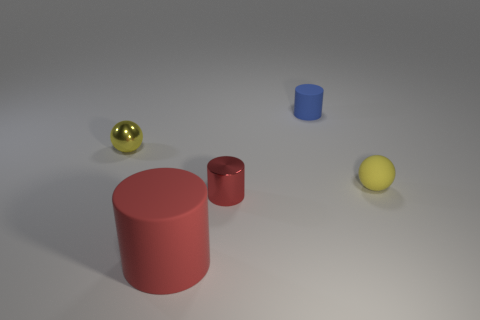Is there any other thing that has the same size as the red matte thing?
Your answer should be compact. No. The big red thing has what shape?
Give a very brief answer. Cylinder. How many small red objects are made of the same material as the blue cylinder?
Keep it short and to the point. 0. There is a tiny cylinder that is made of the same material as the big object; what is its color?
Keep it short and to the point. Blue. There is a yellow sphere that is left of the blue object; is it the same size as the small yellow rubber object?
Give a very brief answer. Yes. The big matte object that is the same shape as the small blue object is what color?
Your answer should be very brief. Red. The metal object that is behind the tiny yellow matte ball in front of the yellow thing that is to the left of the tiny blue rubber cylinder is what shape?
Provide a short and direct response. Sphere. Do the yellow metallic object and the tiny red thing have the same shape?
Offer a very short reply. No. What is the shape of the small object that is in front of the yellow sphere that is to the right of the large rubber object?
Provide a short and direct response. Cylinder. Are there any matte cylinders?
Ensure brevity in your answer.  Yes. 